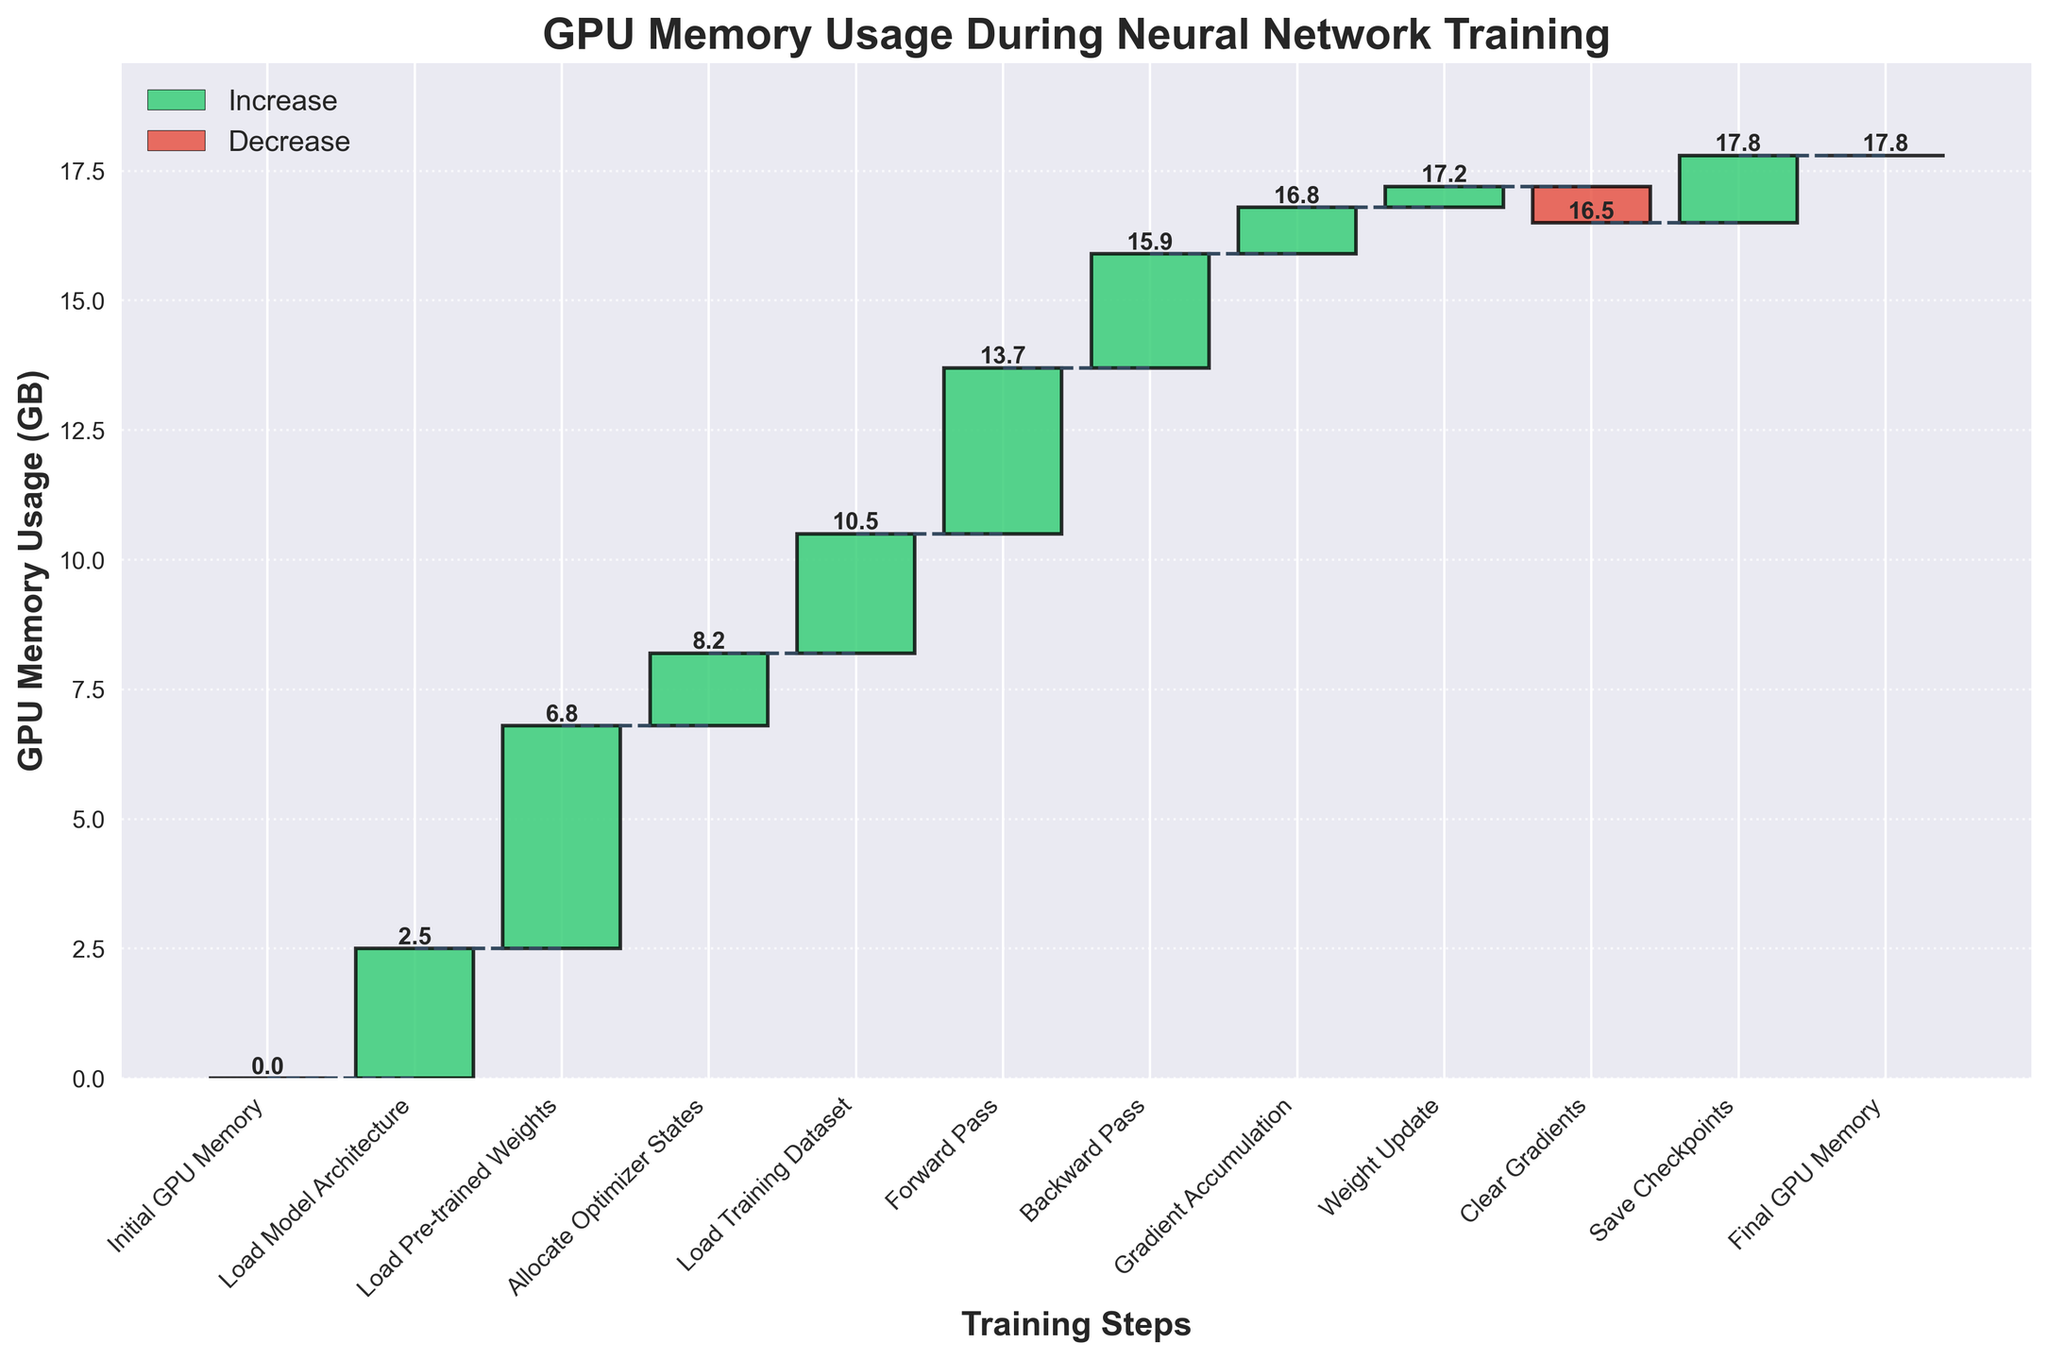What's the total GPU memory used at the end of the training process? The final data point in the plot is labeled "Final GPU Memory," and the corresponding GPU memory usage is 17.8 GB
Answer: 17.8 GB Which training step caused the highest increase in GPU memory usage? By examining the bar heights in the plot, the tallest bar represents "Load Pre-trained Weights" with a change of 4.3 GB
Answer: Load Pre-trained Weights What's the change in GPU memory usage during the Forward Pass and Backward Pass combined? The changes are shown in the plot: Forward Pass causes an increase of 3.2 GB and Backward Pass causes an increase of 2.2 GB. Adding these gives 3.2 + 2.2 = 5.4 GB
Answer: 5.4 GB What is the total number of steps shown in the plot? Counting all the labeled steps in the x-axis, there are 12 steps including the initial and final GPU memory
Answer: 12 By how much does the GPU memory usage decrease during the Clear Gradients step? The plot shows a negative change for "Clear Gradients", labeled as -0.7 GB
Answer: -0.7 GB During which training steps does the GPU memory not change? Checking the plot, the two steps labeled with a 0 GB change are "Initial GPU Memory" and "Final GPU Memory"
Answer: Initial GPU Memory, Final GPU Memory What is the total increase in GPU memory usage due to loading the model and pre-trained weights? The plot shows "Load Model Architecture" with a change of 2.5 GB and "Load Pre-trained Weights" with a change of 4.3 GB. Summing these gives 2.5 + 4.3 = 6.8 GB
Answer: 6.8 GB How does the GPU memory usage change from Allocate Optimizer States to Load Training Dataset? The plot indicates 8.2 GB for "Allocate Optimizer States" and an increase of 2.3 GB for "Load Training Dataset," summing to 8.2 + 2.3 = 10.5 GB
Answer: 10.5 GB Which step has the smallest positive change in GPU memory usage? The plot shows the smallest positive increase with "Weight Update," labeled as 0.4 GB
Answer: Weight Update 